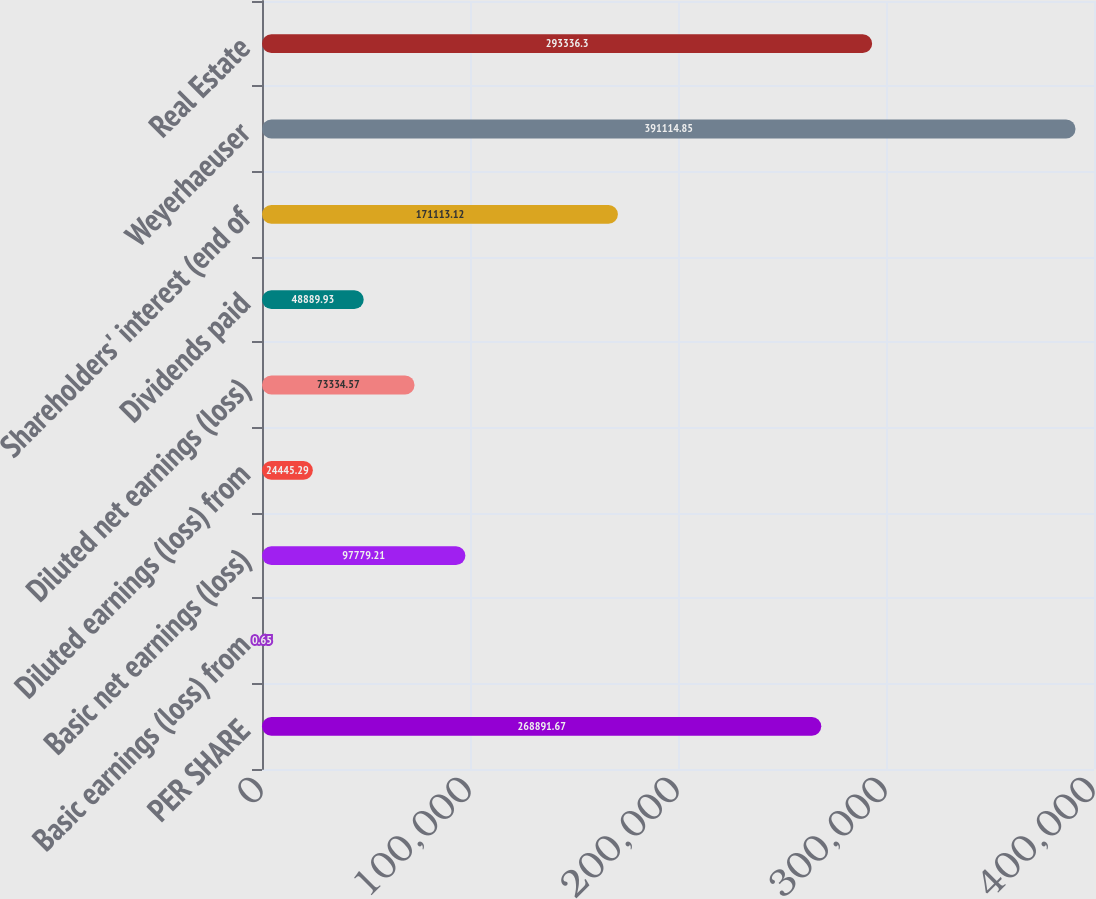<chart> <loc_0><loc_0><loc_500><loc_500><bar_chart><fcel>PER SHARE<fcel>Basic earnings (loss) from<fcel>Basic net earnings (loss)<fcel>Diluted earnings (loss) from<fcel>Diluted net earnings (loss)<fcel>Dividends paid<fcel>Shareholders' interest (end of<fcel>Weyerhaeuser<fcel>Real Estate<nl><fcel>268892<fcel>0.65<fcel>97779.2<fcel>24445.3<fcel>73334.6<fcel>48889.9<fcel>171113<fcel>391115<fcel>293336<nl></chart> 